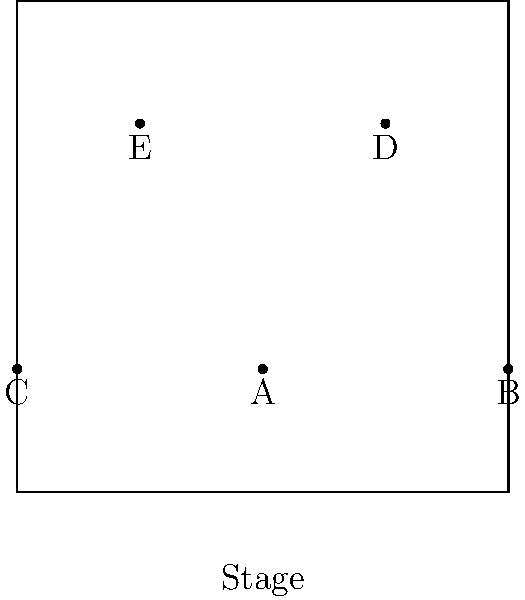In a five-member dance formation, positions are marked A, B, C, D, and E on the stage. If the choreography requires a diamond shape with one member at the center, which position should the center dancer take to maintain the most balanced formation? To determine the most balanced diamond formation with one member at the center, we need to follow these steps:

1. Identify the current formation:
   A is at (0,0), B at (2,0), C at (-2,0), D at (1,2), and E at (-1,2).

2. Visualize a diamond shape:
   The diamond should have four points forming a rhombus with equal sides.

3. Analyze possible center positions:
   - Position A is already at the center (0,0).
   - Positions B and C are too far to the sides.
   - Positions D and E are too far forward.

4. Consider balance:
   A diamond with A at the center would have:
   - B and C forming the side points
   - D and E forming the front and back points

5. Evaluate symmetry:
   With A at the center:
   - B and C are equidistant and opposite
   - D and E are equidistant and opposite
   This creates perfect symmetry and balance.

Therefore, position A provides the most balanced formation for the center of the diamond shape.
Answer: A 